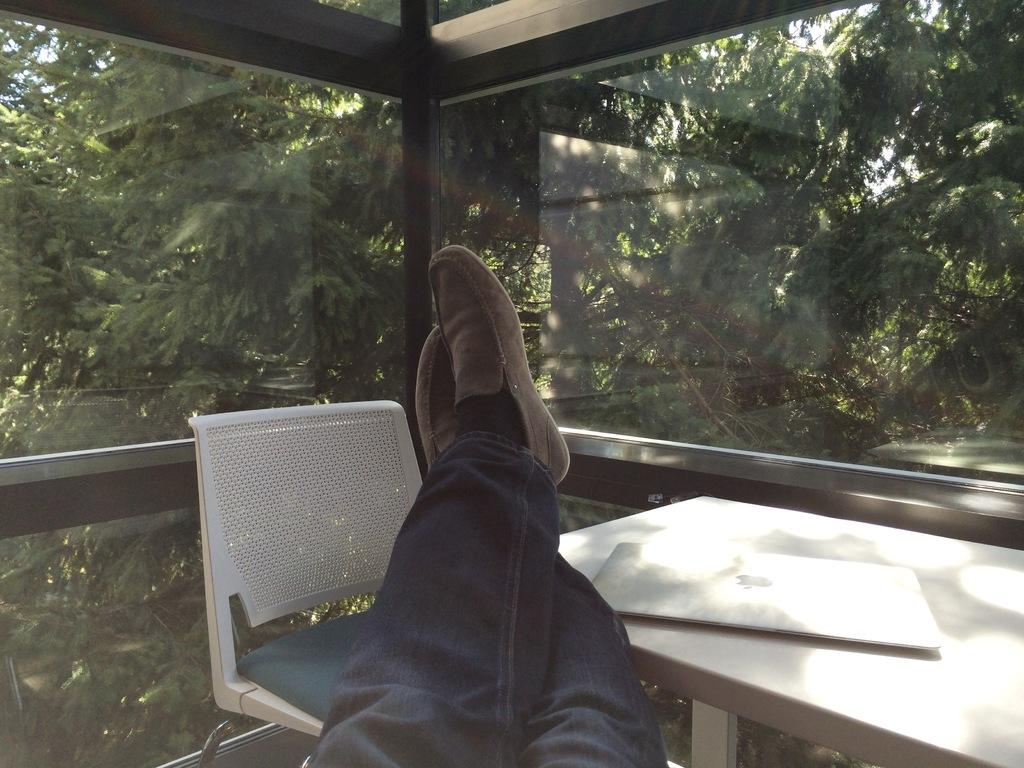What body part is visible in the image? There are person's legs in the image. What electronic device is present on a table in the image? There is a laptop on a table in the image. What type of furniture is located beside the table in the image? There is a chair beside the table in the image. What architectural feature allows natural light into the room in the image? There are glass windows in the image. What type of vegetation can be seen through the windows in the image? Trees are visible through the windows in the image. What type of tub is visible in the image? There is no tub present in the image. 